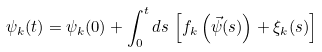<formula> <loc_0><loc_0><loc_500><loc_500>\psi _ { k } ( t ) = \psi _ { k } ( 0 ) + \int _ { 0 } ^ { t } d s \, \left [ f _ { k } \left ( \vec { \psi } ( s ) \right ) + \xi _ { k } ( s ) \right ]</formula> 